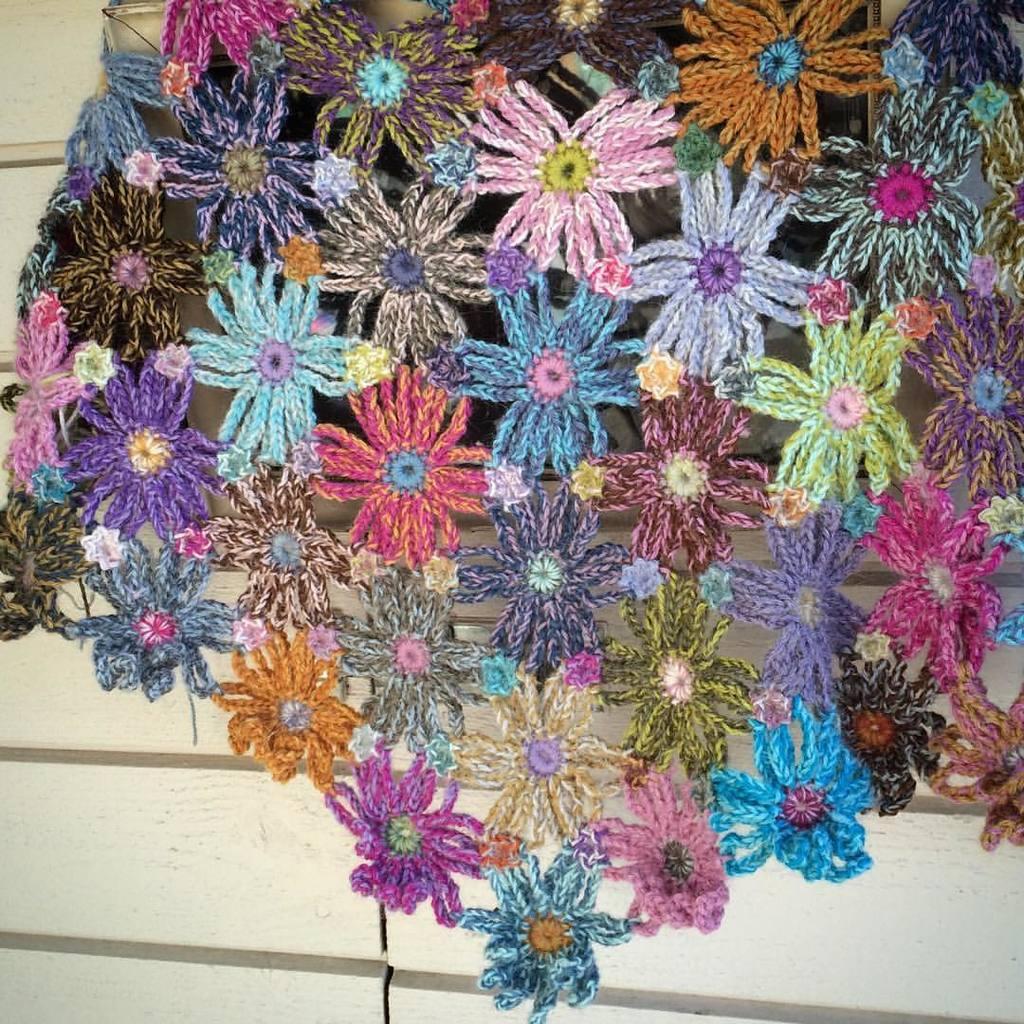How would you summarize this image in a sentence or two? In the center of this picture we can see the woolen craft and in the background we can see the wall and some other items. 